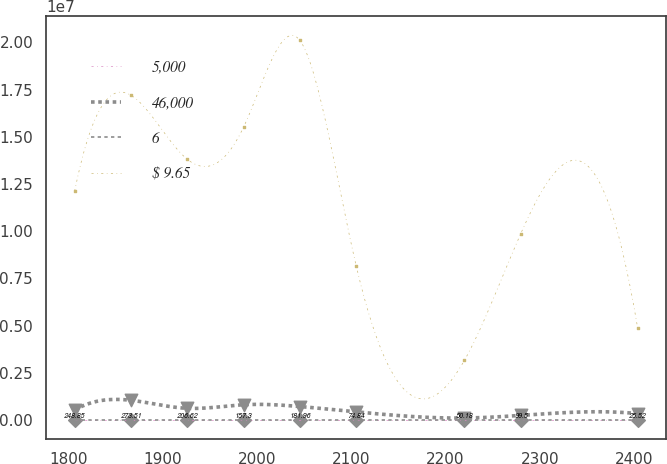Convert chart. <chart><loc_0><loc_0><loc_500><loc_500><line_chart><ecel><fcel>5,000<fcel>46,000<fcel>6<fcel>$ 9.65<nl><fcel>1806.67<fcel>248.85<fcel>528519<fcel>8.75<fcel>1.21181e+07<nl><fcel>1866.39<fcel>273.51<fcel>1.04638e+06<fcel>17.89<fcel>1.72022e+07<nl><fcel>1926.11<fcel>206.62<fcel>622348<fcel>10.35<fcel>1.38128e+07<nl><fcel>1985.83<fcel>157.3<fcel>810006<fcel>11.95<fcel>1.55075e+07<nl><fcel>2045.55<fcel>181.96<fcel>716177<fcel>13.55<fcel>2.01077e+07<nl><fcel>2105.27<fcel>74.84<fcel>434690<fcel>5.33<fcel>8.17533e+06<nl><fcel>2220.07<fcel>50.18<fcel>108086<fcel>1.91<fcel>3.16085e+06<nl><fcel>2279.79<fcel>99.5<fcel>247032<fcel>6.93<fcel>9.87002e+06<nl><fcel>2403.88<fcel>25.52<fcel>340861<fcel>3.73<fcel>4.85554e+06<nl></chart> 